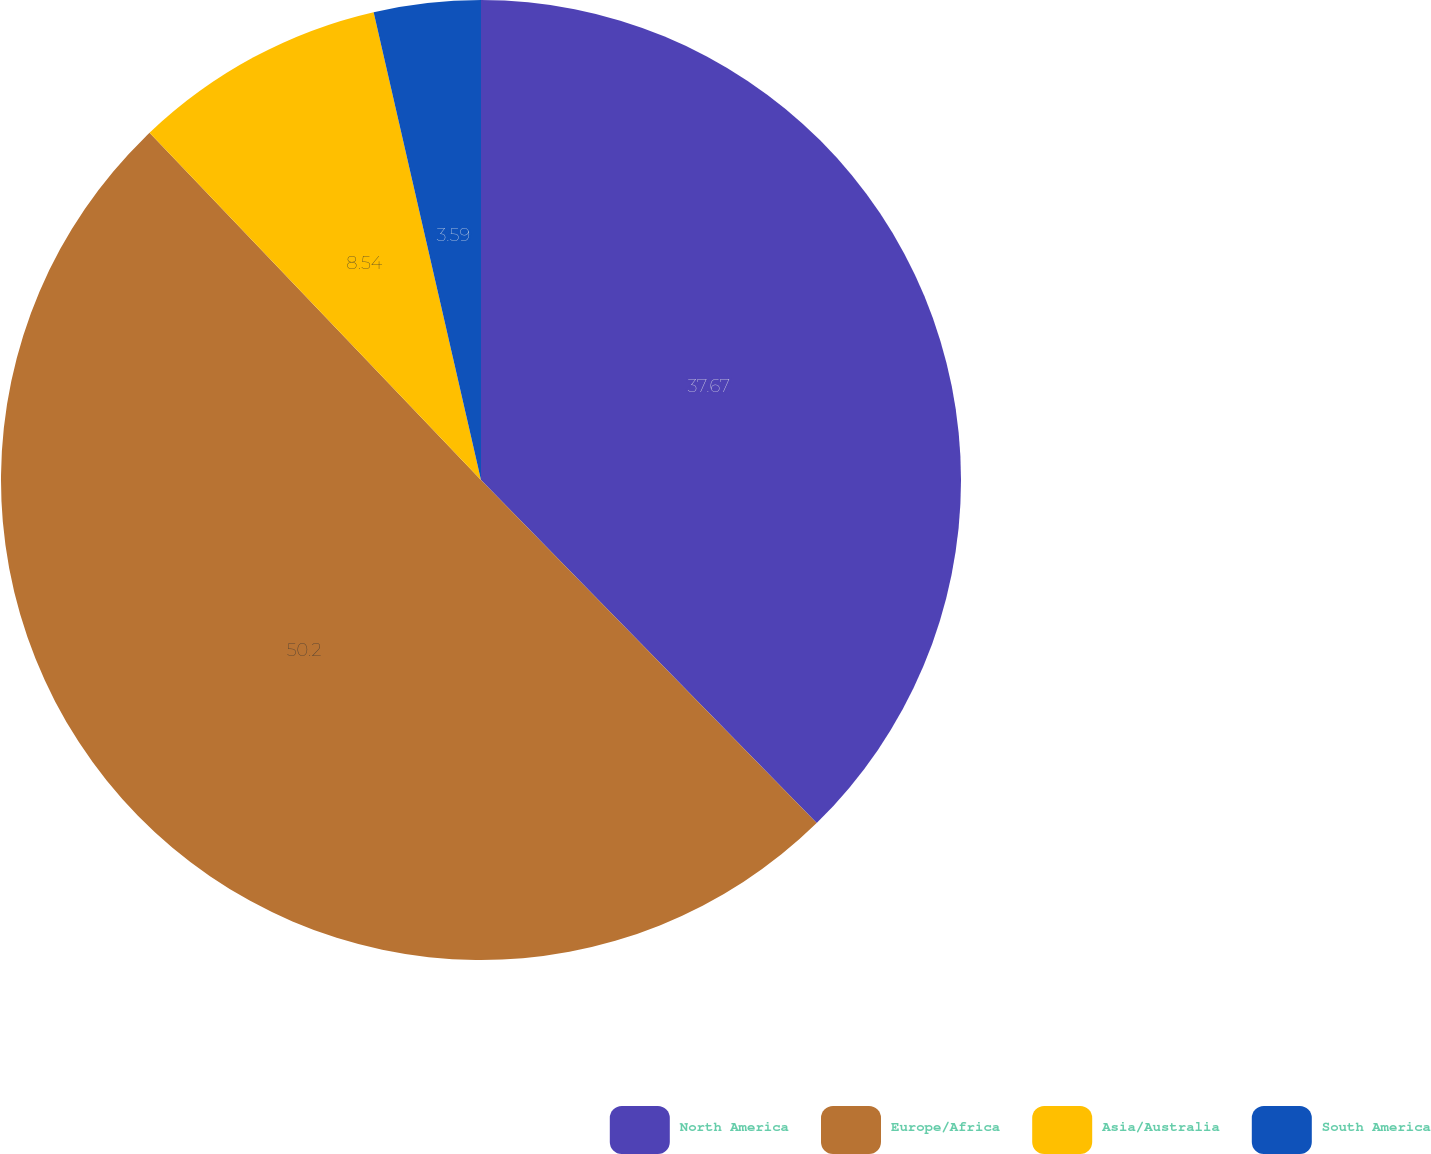<chart> <loc_0><loc_0><loc_500><loc_500><pie_chart><fcel>North America<fcel>Europe/Africa<fcel>Asia/Australia<fcel>South America<nl><fcel>37.67%<fcel>50.19%<fcel>8.54%<fcel>3.59%<nl></chart> 